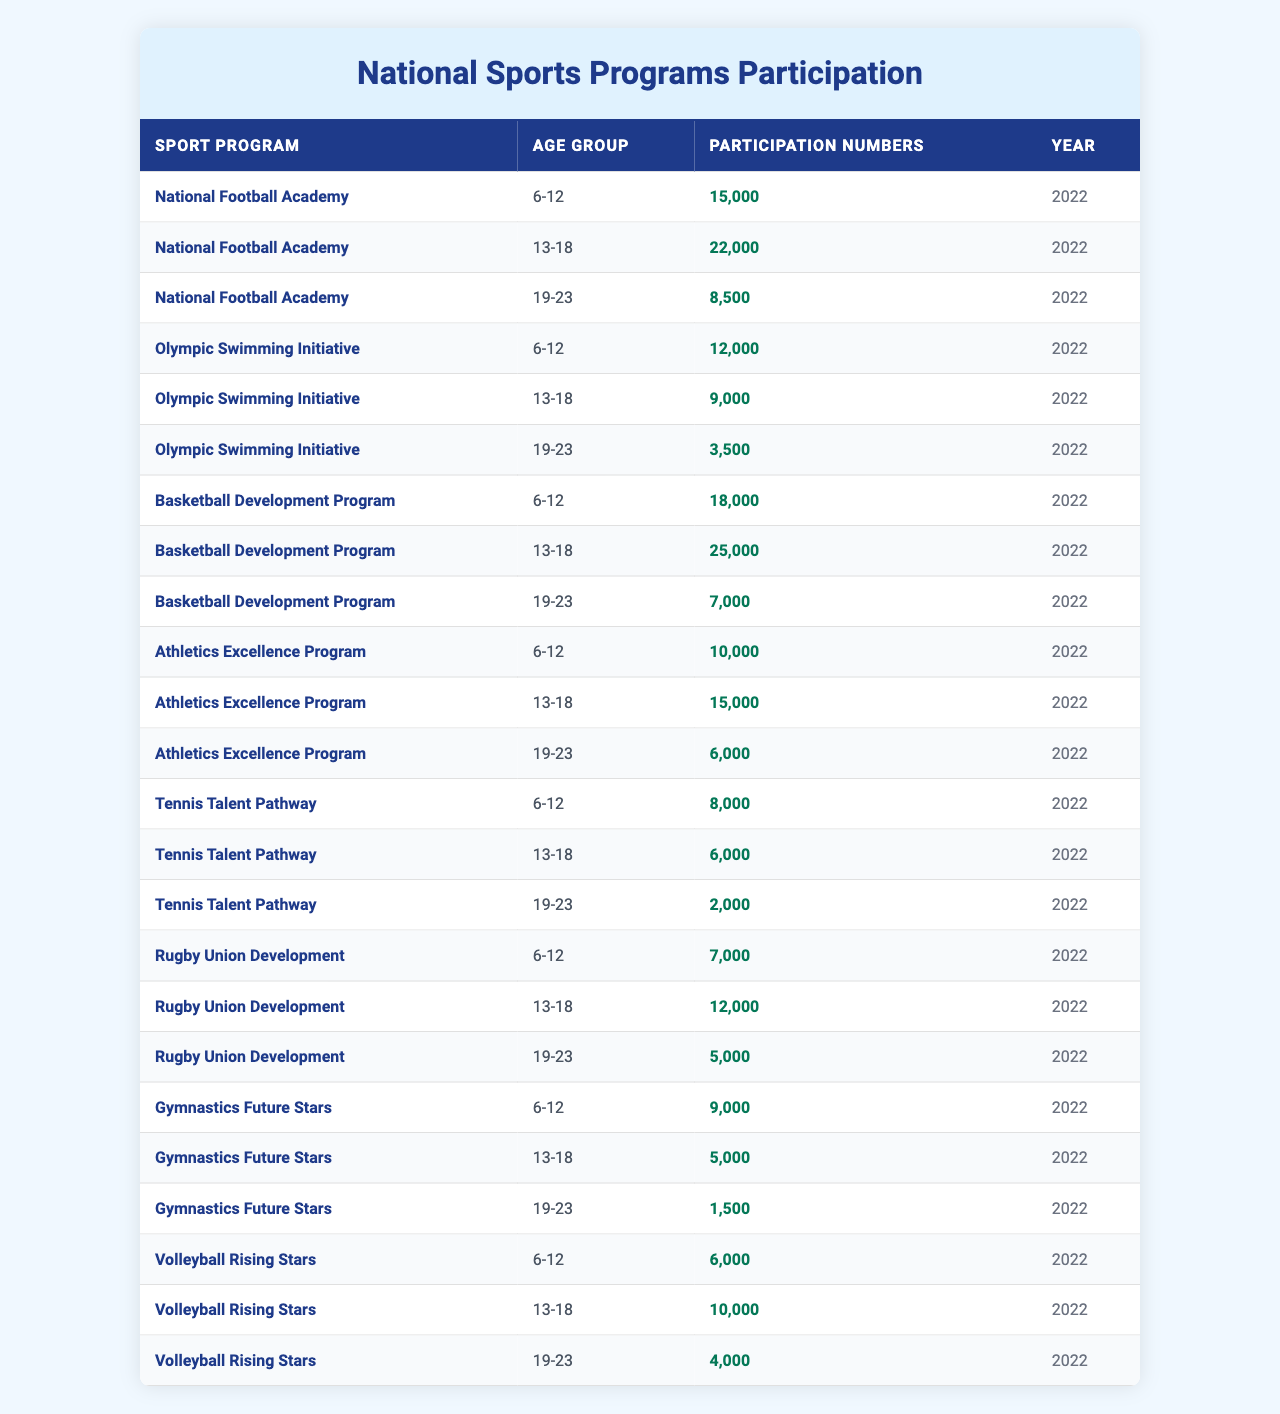What is the participation number for the National Football Academy in the 6-12 age group? Looking at the table, under the "National Football Academy" and "6-12" age group, the participation number listed is 15,000.
Answer: 15,000 How many participants are there in the Olympic Swimming Initiative for the 19-23 age group? Referring to the table, we find that the "Olympic Swimming Initiative" for the "19-23" age group has 3,500 participants.
Answer: 3,500 Which sport program has the highest participation in the 13-18 age group? In the table, comparing the participation numbers for the "13-18" age group across all sport programs, "Basketball Development Program" has the highest number, with 25,000 participants.
Answer: Basketball Development Program What is the total participation for the Athletics Excellence Program across all age groups? Summing up the participation numbers for "Athletics Excellence Program" from the table: 10,000 (6-12) + 15,000 (13-18) + 6,000 (19-23) = 31,000.
Answer: 31,000 Is there any age group in the Tennis Talent Pathway that has more than 8,000 participants? Checking the table, we find that for the "Tennis Talent Pathway," the age group "6-12" has 8,000 participants, but both "13-18" (6,000) and "19-23" (2,000) have less. Therefore, there is no age group exceeding 8,000.
Answer: No What percentage of participants in the Basketball Development Program are aged 13-18? First, we calculate the total participation for the "Basketball Development Program": 18,000 (6-12) + 25,000 (13-18) + 7,000 (19-23) = 50,000. Then, we find the percentage for the "13-18" age group: (25,000 / 50,000) * 100 = 50%.
Answer: 50% Which sport program shows the least participation in the 19-23 age group? From the table, we examine the participation numbers for the "19-23" age group: 8,500 (National Football Academy), 3,500 (Olympic Swimming Initiative), 7,000 (Basketball Development Program), 6,000 (Athletics Excellence Program), 2,000 (Tennis Talent Pathway), 5,000 (Rugby Union Development), 1,500 (Gymnastics Future Stars), and 4,000 (Volleyball Rising Stars). The least is 1,500 from "Gymnastics Future Stars."
Answer: Gymnastics Future Stars What is the difference in participation between the 6-12 and 13-18 age groups for the Rugby Union Development program? The participation numbers for the "Rugby Union Development" are 7,000 (6-12) and 12,000 (13-18). The difference is calculated as 12,000 - 7,000 = 5,000.
Answer: 5,000 Across all sport programs, which age group has the highest total participation? We need to sum the participation numbers for each age group across all programs. The sums are: 6-12 = 15,000 + 12,000 + 18,000 + 10,000 + 8,000 + 7,000 + 9,000 + 6,000 = 85,000; 13-18 = 22,000 + 9,000 + 25,000 + 15,000 + 6,000 + 12,000 + 5,000 + 10,000 = 104,000; 19-23 = 8,500 + 3,500 + 7,000 + 6,000 + 2,000 + 5,000 + 1,500 + 4,000 = 33,500. The highest total participation is for the 13-18 age group with 104,000 participants.
Answer: 13-18 age group How many more participants are there in Basketball Development Program than in Olympic Swimming Initiative across all age groups? The total for "Basketball Development Program" is 50,000 (18,000 + 25,000 + 7,000) and for "Olympic Swimming Initiative" is 22,500 (12,000 + 9,000 + 3,500). The difference is 50,000 - 22,500 = 27,500.
Answer: 27,500 